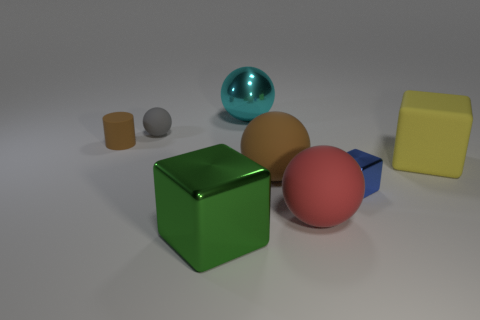Is the shape of the yellow object the same as the big thing that is to the left of the cyan shiny object?
Keep it short and to the point. Yes. How many other objects are there of the same material as the tiny brown object?
Give a very brief answer. 4. There is a small rubber cylinder; is it the same color as the large matte object left of the big red rubber sphere?
Offer a terse response. Yes. What is the large ball behind the brown ball made of?
Your answer should be compact. Metal. Is there a object of the same color as the matte cylinder?
Make the answer very short. Yes. What color is the rubber cylinder that is the same size as the gray ball?
Give a very brief answer. Brown. What number of large things are either brown matte cylinders or yellow matte things?
Provide a short and direct response. 1. Is the number of large objects that are in front of the gray rubber thing the same as the number of big objects that are in front of the big cyan ball?
Offer a terse response. Yes. What number of brown matte objects have the same size as the gray rubber object?
Provide a succinct answer. 1. How many red objects are either large cubes or spheres?
Offer a terse response. 1. 